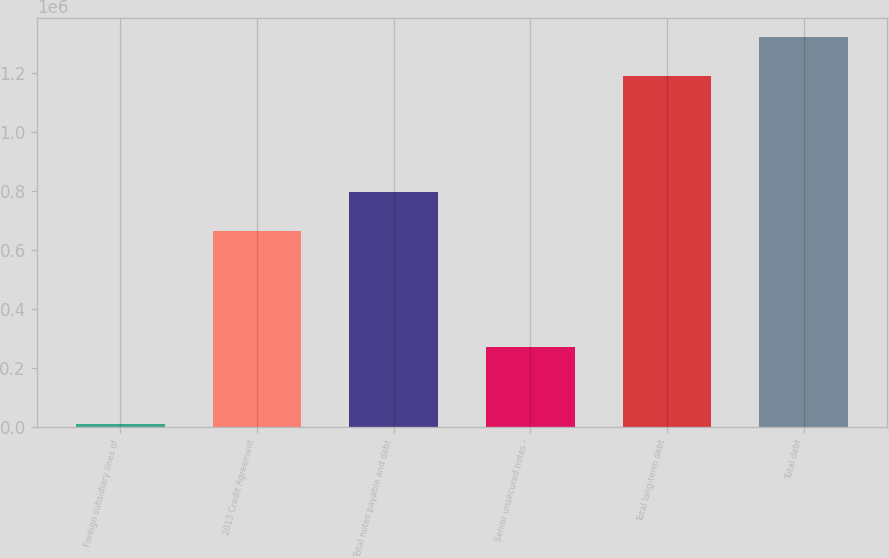Convert chart. <chart><loc_0><loc_0><loc_500><loc_500><bar_chart><fcel>Foreign subsidiary lines of<fcel>2013 Credit Agreement<fcel>Total notes payable and debt<fcel>Senior unsecured notes -<fcel>Total long-term debt<fcel>Total debt<nl><fcel>8346<fcel>665846<fcel>797346<fcel>271346<fcel>1.19e+06<fcel>1.32335e+06<nl></chart> 